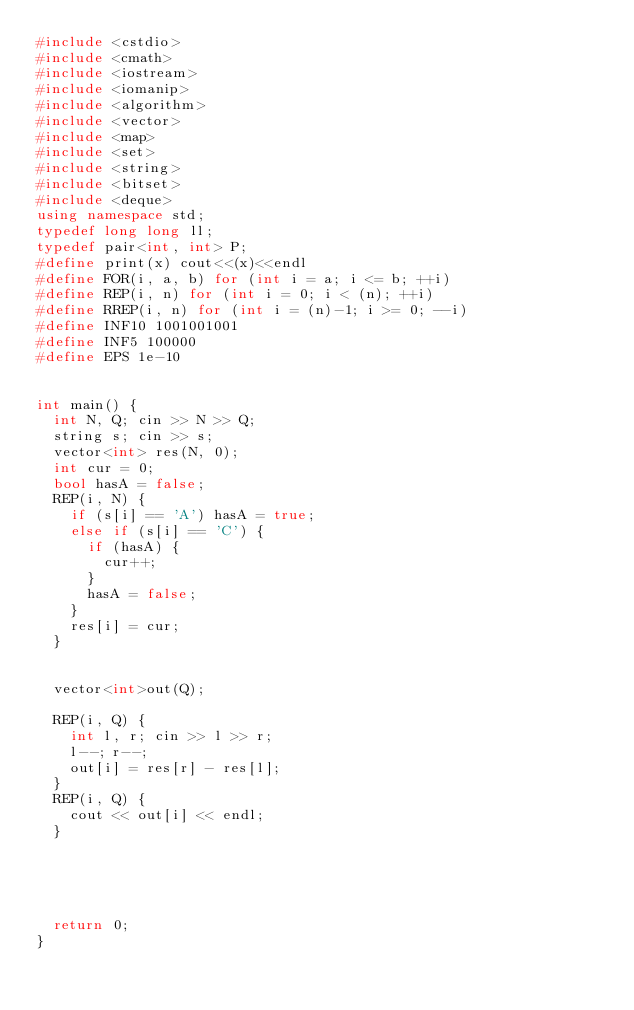<code> <loc_0><loc_0><loc_500><loc_500><_C++_>#include <cstdio>
#include <cmath>
#include <iostream>
#include <iomanip>
#include <algorithm>
#include <vector>
#include <map>
#include <set>
#include <string>
#include <bitset>
#include <deque>
using namespace std;
typedef long long ll;
typedef pair<int, int> P;
#define print(x) cout<<(x)<<endl
#define FOR(i, a, b) for (int i = a; i <= b; ++i)
#define REP(i, n) for (int i = 0; i < (n); ++i)
#define RREP(i, n) for (int i = (n)-1; i >= 0; --i)
#define INF10 1001001001 
#define INF5 100000
#define EPS 1e-10


int main() {
	int N, Q; cin >> N >> Q;
	string s; cin >> s;
	vector<int> res(N, 0);
	int cur = 0;
	bool hasA = false;
	REP(i, N) {
		if (s[i] == 'A') hasA = true;
		else if (s[i] == 'C') {
			if (hasA) {
				cur++;
			}
			hasA = false;
		}
		res[i] = cur;
	}


	vector<int>out(Q);

	REP(i, Q) {
		int l, r; cin >> l >> r;
		l--; r--;
		out[i] = res[r] - res[l];
	}
	REP(i, Q) {
		cout << out[i] << endl;
	}





	return 0;
}
</code> 